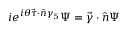<formula> <loc_0><loc_0><loc_500><loc_500>i e ^ { i \theta \vec { \tau } \cdot \hat { n } \gamma _ { 5 } } \Psi = \vec { \gamma } \cdot \hat { n } \Psi</formula> 